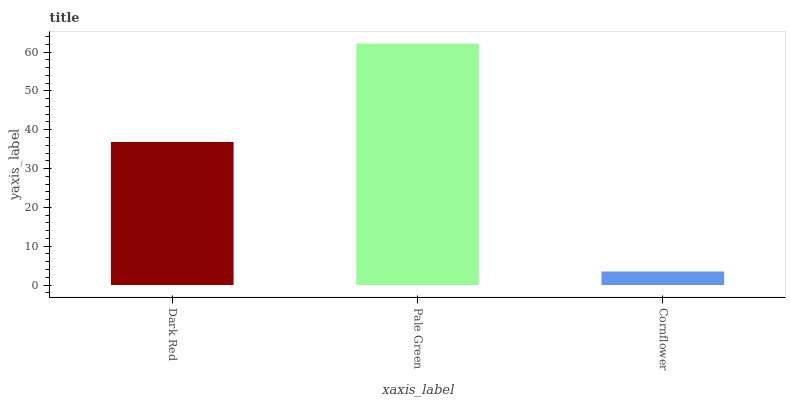Is Cornflower the minimum?
Answer yes or no. Yes. Is Pale Green the maximum?
Answer yes or no. Yes. Is Pale Green the minimum?
Answer yes or no. No. Is Cornflower the maximum?
Answer yes or no. No. Is Pale Green greater than Cornflower?
Answer yes or no. Yes. Is Cornflower less than Pale Green?
Answer yes or no. Yes. Is Cornflower greater than Pale Green?
Answer yes or no. No. Is Pale Green less than Cornflower?
Answer yes or no. No. Is Dark Red the high median?
Answer yes or no. Yes. Is Dark Red the low median?
Answer yes or no. Yes. Is Cornflower the high median?
Answer yes or no. No. Is Pale Green the low median?
Answer yes or no. No. 